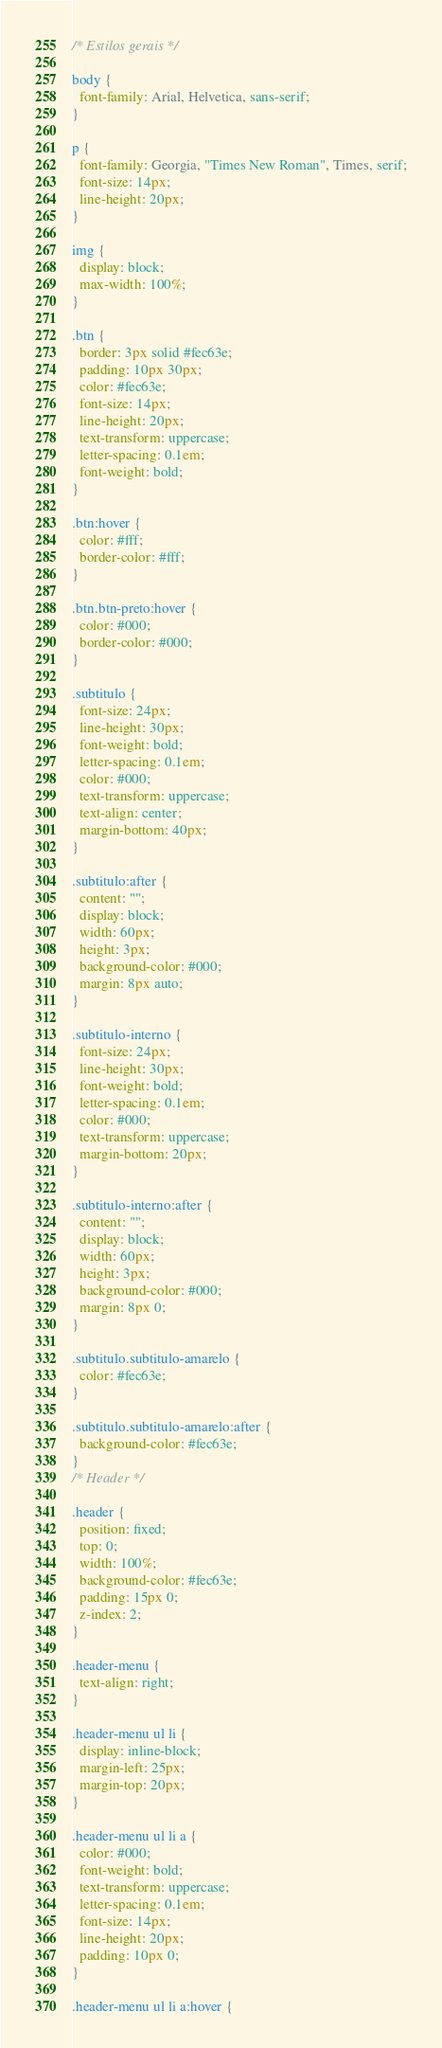Convert code to text. <code><loc_0><loc_0><loc_500><loc_500><_CSS_>/* Estilos gerais */

body {
  font-family: Arial, Helvetica, sans-serif;
}

p {
  font-family: Georgia, "Times New Roman", Times, serif;
  font-size: 14px;
  line-height: 20px;
}

img {
  display: block;
  max-width: 100%;
}

.btn {
  border: 3px solid #fec63e;
  padding: 10px 30px;
  color: #fec63e;
  font-size: 14px;
  line-height: 20px;
  text-transform: uppercase;
  letter-spacing: 0.1em;
  font-weight: bold;
}

.btn:hover {
  color: #fff;
  border-color: #fff;
}

.btn.btn-preto:hover {
  color: #000;
  border-color: #000;
}

.subtitulo {
  font-size: 24px;
  line-height: 30px;
  font-weight: bold;
  letter-spacing: 0.1em;
  color: #000;
  text-transform: uppercase;
  text-align: center;
  margin-bottom: 40px;
}

.subtitulo:after {
  content: "";
  display: block;
  width: 60px;
  height: 3px;
  background-color: #000;
  margin: 8px auto;
}

.subtitulo-interno {
  font-size: 24px;
  line-height: 30px;
  font-weight: bold;
  letter-spacing: 0.1em;
  color: #000;
  text-transform: uppercase;
  margin-bottom: 20px;
}

.subtitulo-interno:after {
  content: "";
  display: block;
  width: 60px;
  height: 3px;
  background-color: #000;
  margin: 8px 0;
}

.subtitulo.subtitulo-amarelo {
  color: #fec63e;
}

.subtitulo.subtitulo-amarelo:after {
  background-color: #fec63e;
}
/* Header */

.header {
  position: fixed;
  top: 0;
  width: 100%;
  background-color: #fec63e;
  padding: 15px 0;
  z-index: 2;
}

.header-menu {
  text-align: right;
}

.header-menu ul li {
  display: inline-block;
  margin-left: 25px;
  margin-top: 20px;
}

.header-menu ul li a {
  color: #000;
  font-weight: bold;
  text-transform: uppercase;
  letter-spacing: 0.1em;
  font-size: 14px;
  line-height: 20px;
  padding: 10px 0;
}

.header-menu ul li a:hover {</code> 